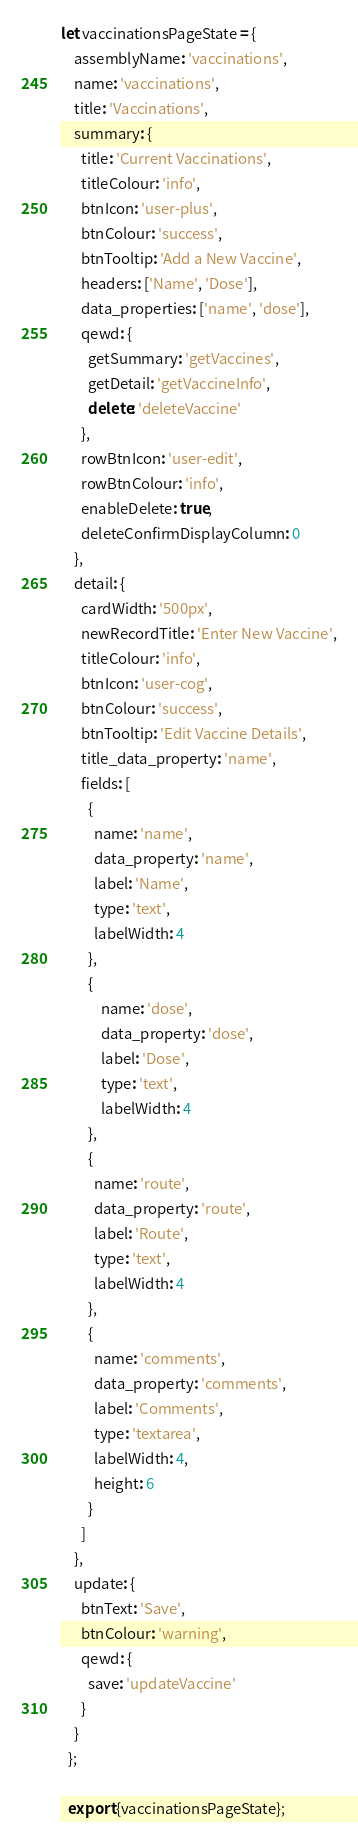<code> <loc_0><loc_0><loc_500><loc_500><_JavaScript_>let vaccinationsPageState = {
    assemblyName: 'vaccinations',
    name: 'vaccinations',
    title: 'Vaccinations',
    summary: {
      title: 'Current Vaccinations',
      titleColour: 'info',
      btnIcon: 'user-plus',
      btnColour: 'success',
      btnTooltip: 'Add a New Vaccine',
      headers: ['Name', 'Dose'],
      data_properties: ['name', 'dose'],
      qewd: {
        getSummary: 'getVaccines',
        getDetail: 'getVaccineInfo',
        delete: 'deleteVaccine'
      },
      rowBtnIcon: 'user-edit',
      rowBtnColour: 'info',
      enableDelete: true,
      deleteConfirmDisplayColumn: 0
    },
    detail: {
      cardWidth: '500px',
      newRecordTitle: 'Enter New Vaccine',
      titleColour: 'info',
      btnIcon: 'user-cog',
      btnColour: 'success',
      btnTooltip: 'Edit Vaccine Details',
      title_data_property: 'name',
      fields: [
        {
          name: 'name',
          data_property: 'name',
          label: 'Name',
          type: 'text',
          labelWidth: 4
        },
        {
            name: 'dose',
            data_property: 'dose',
            label: 'Dose',
            type: 'text',
            labelWidth: 4
        },
        {
          name: 'route',
          data_property: 'route',
          label: 'Route',
          type: 'text',
          labelWidth: 4
        },
        {
          name: 'comments',
          data_property: 'comments',
          label: 'Comments',
          type: 'textarea',
          labelWidth: 4,
          height: 6
        }
      ]
    },
    update: {
      btnText: 'Save',
      btnColour: 'warning',
      qewd: {
        save: 'updateVaccine'
      }
    }
  };

  export {vaccinationsPageState};</code> 